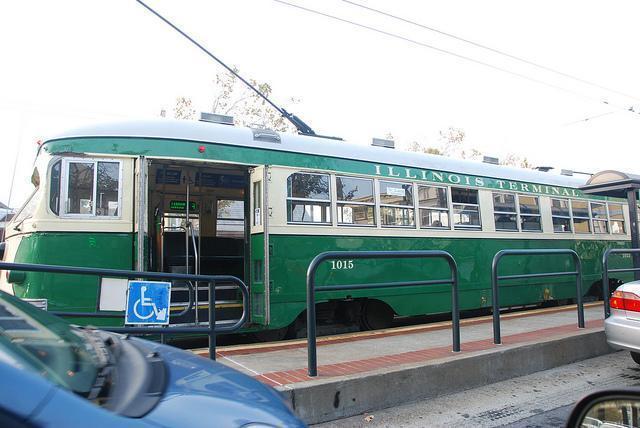What is available according to the blue sign?
Answer the question by selecting the correct answer among the 4 following choices.
Options: Snacks, bathrooms, movies, handicap seats. Handicap seats. 